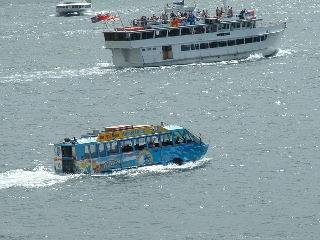What types of boats are present in the image, and what do you think their purposes might be? The image showcases two distinct types of boats. The larger boat appears to be a passenger ferry, likely used for transporting people across this body of water. The smaller, more colorful one looks like an amphibious tour bus, designed for both land and water tours. Its vivid decoration suggests it's geared towards tourists seeking a unique sightseeing experience. 